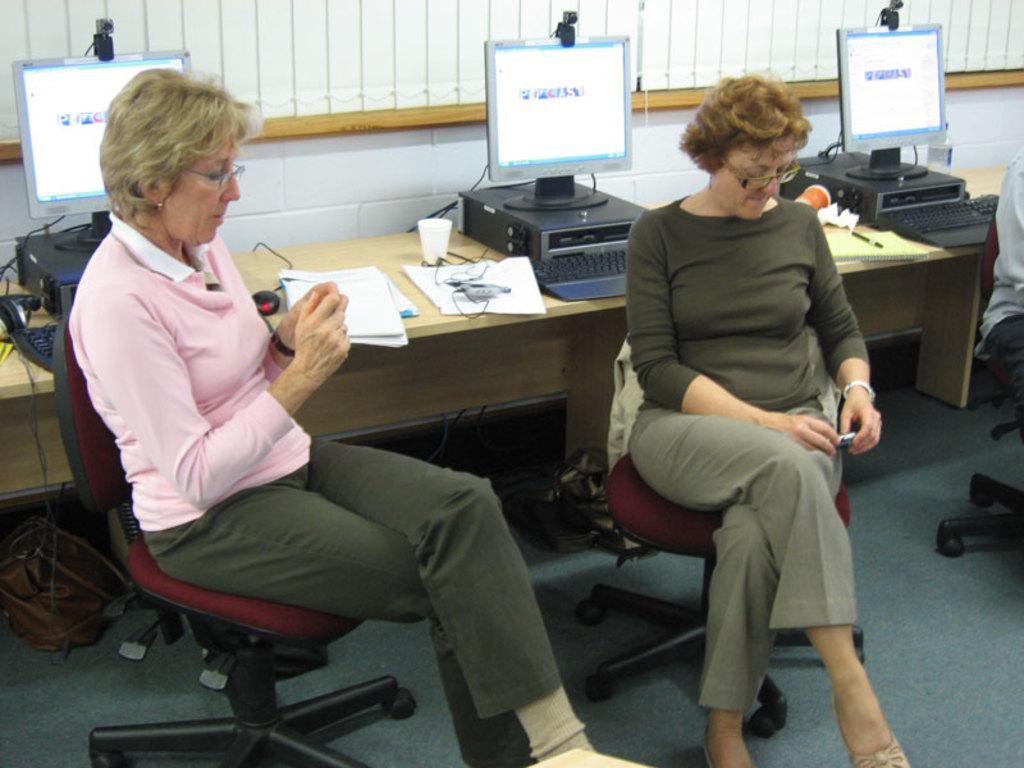Please provide a concise description of this image. This picture shows two men seated on the chairs and both are holding a mobile in their hands and we see three computers on the table and we see few papers and cups on the table 